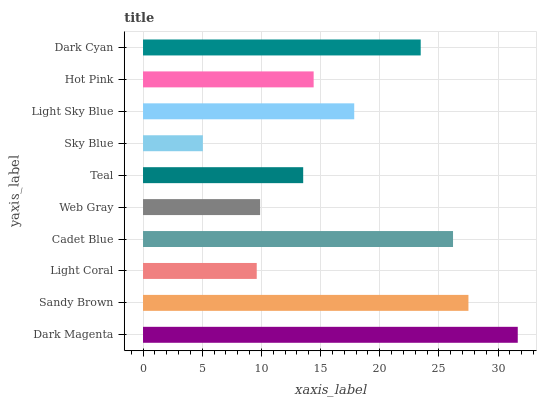Is Sky Blue the minimum?
Answer yes or no. Yes. Is Dark Magenta the maximum?
Answer yes or no. Yes. Is Sandy Brown the minimum?
Answer yes or no. No. Is Sandy Brown the maximum?
Answer yes or no. No. Is Dark Magenta greater than Sandy Brown?
Answer yes or no. Yes. Is Sandy Brown less than Dark Magenta?
Answer yes or no. Yes. Is Sandy Brown greater than Dark Magenta?
Answer yes or no. No. Is Dark Magenta less than Sandy Brown?
Answer yes or no. No. Is Light Sky Blue the high median?
Answer yes or no. Yes. Is Hot Pink the low median?
Answer yes or no. Yes. Is Sandy Brown the high median?
Answer yes or no. No. Is Sandy Brown the low median?
Answer yes or no. No. 